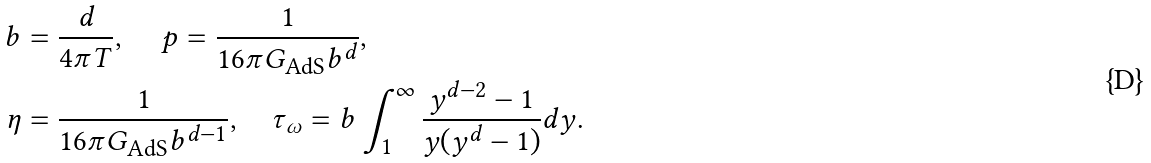Convert formula to latex. <formula><loc_0><loc_0><loc_500><loc_500>b & = \frac { d } { 4 \pi T } , \quad \, p = \frac { 1 } { 1 6 \pi G _ { \text {AdS} } b ^ { d } } , \\ \eta & = \frac { 1 } { 1 6 \pi G _ { \text {AdS} } b ^ { d - 1 } } , \quad \tau _ { \omega } = b \int _ { 1 } ^ { \infty } \frac { y ^ { d - 2 } - 1 } { y ( y ^ { d } - 1 ) } d y .</formula> 